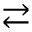Convert formula to latex. <formula><loc_0><loc_0><loc_500><loc_500>\right l e f t a r r o w s</formula> 